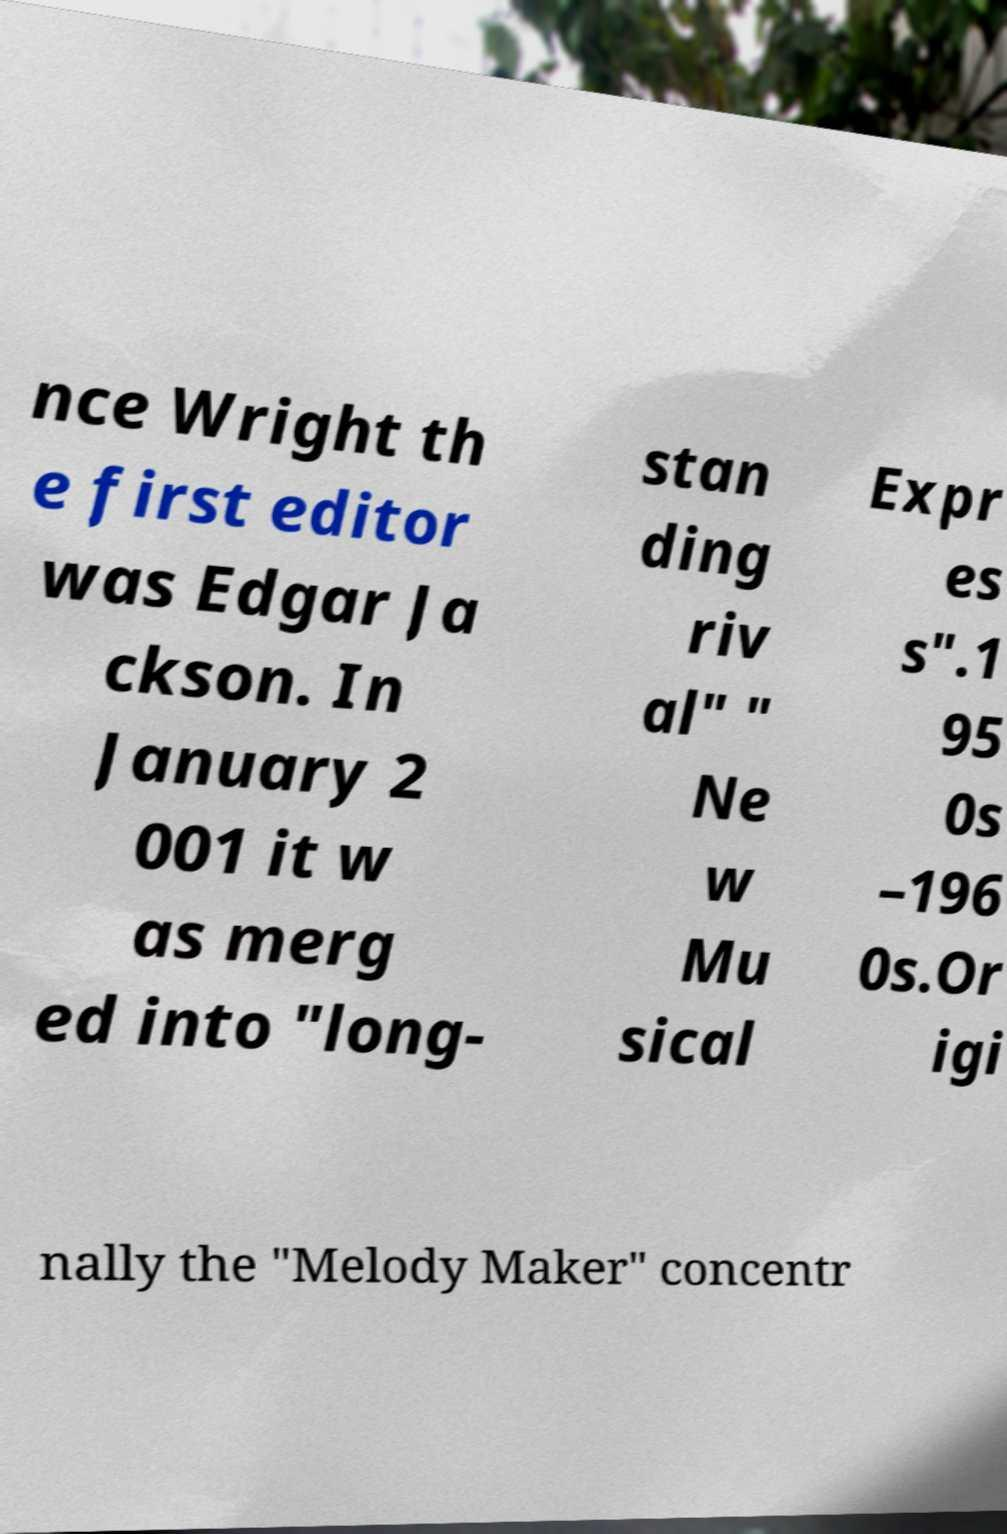Please read and relay the text visible in this image. What does it say? nce Wright th e first editor was Edgar Ja ckson. In January 2 001 it w as merg ed into "long- stan ding riv al" " Ne w Mu sical Expr es s".1 95 0s –196 0s.Or igi nally the "Melody Maker" concentr 